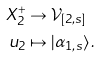<formula> <loc_0><loc_0><loc_500><loc_500>X _ { 2 } ^ { + } & \rightarrow \mathcal { V } _ { [ 2 , s ] } \\ u _ { 2 } & \mapsto | \alpha _ { 1 , s } \rangle \, .</formula> 